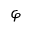Convert formula to latex. <formula><loc_0><loc_0><loc_500><loc_500>\varphi</formula> 